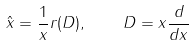<formula> <loc_0><loc_0><loc_500><loc_500>\hat { x } = \frac { 1 } { x } r ( D ) , \quad D = x \frac { d } { d x }</formula> 